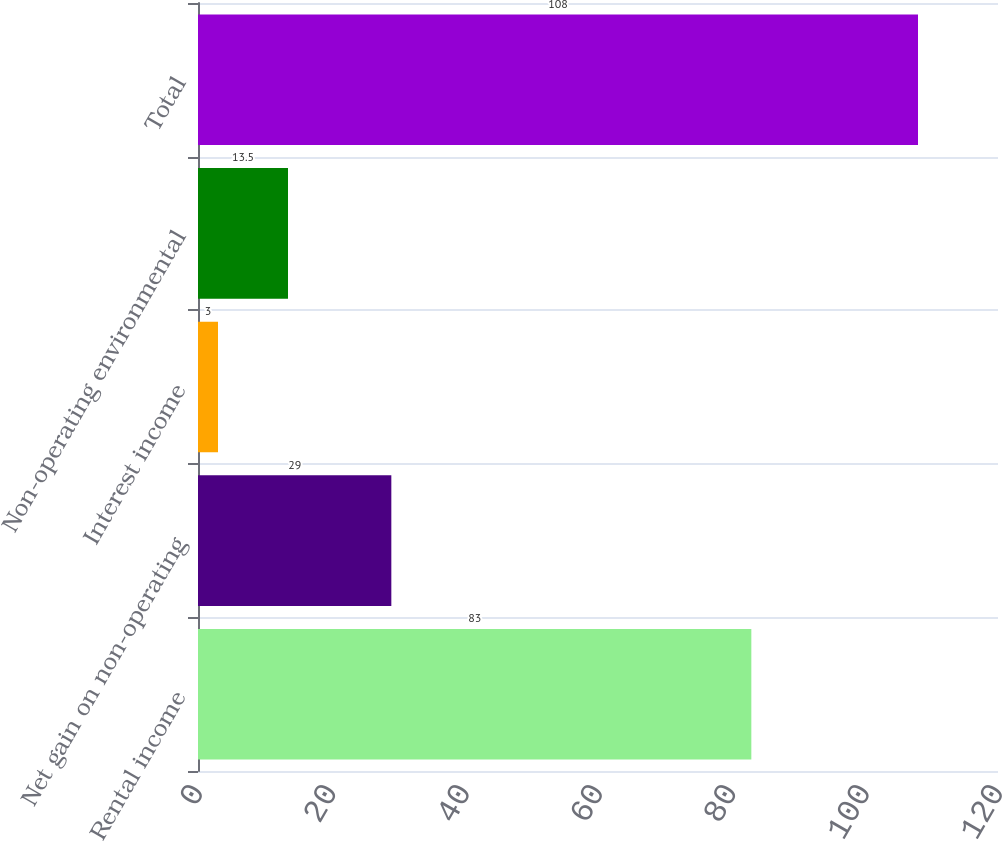Convert chart to OTSL. <chart><loc_0><loc_0><loc_500><loc_500><bar_chart><fcel>Rental income<fcel>Net gain on non-operating<fcel>Interest income<fcel>Non-operating environmental<fcel>Total<nl><fcel>83<fcel>29<fcel>3<fcel>13.5<fcel>108<nl></chart> 